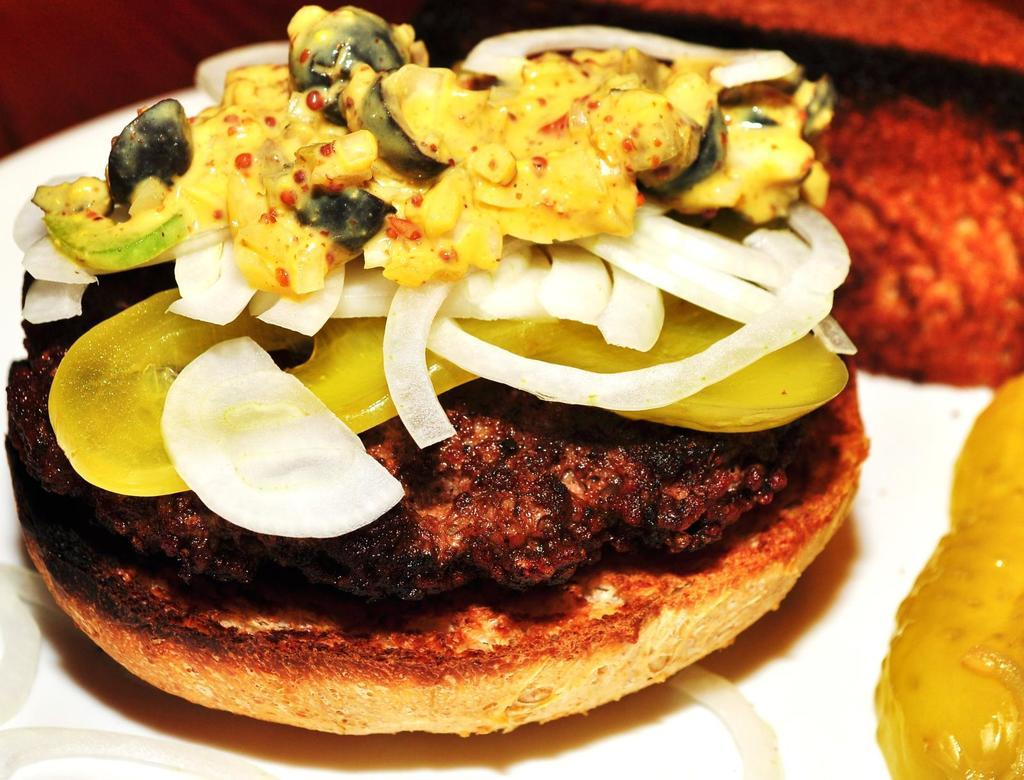What is on the plate in the image? There are food items on a plate. What color is the plate? The plate is white. Are there any flowers on the plate in the image? No, there are no flowers on the plate in the image. Who is the owner of the plate in the image? The image does not provide information about the owner of the plate. 